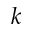<formula> <loc_0><loc_0><loc_500><loc_500>k</formula> 